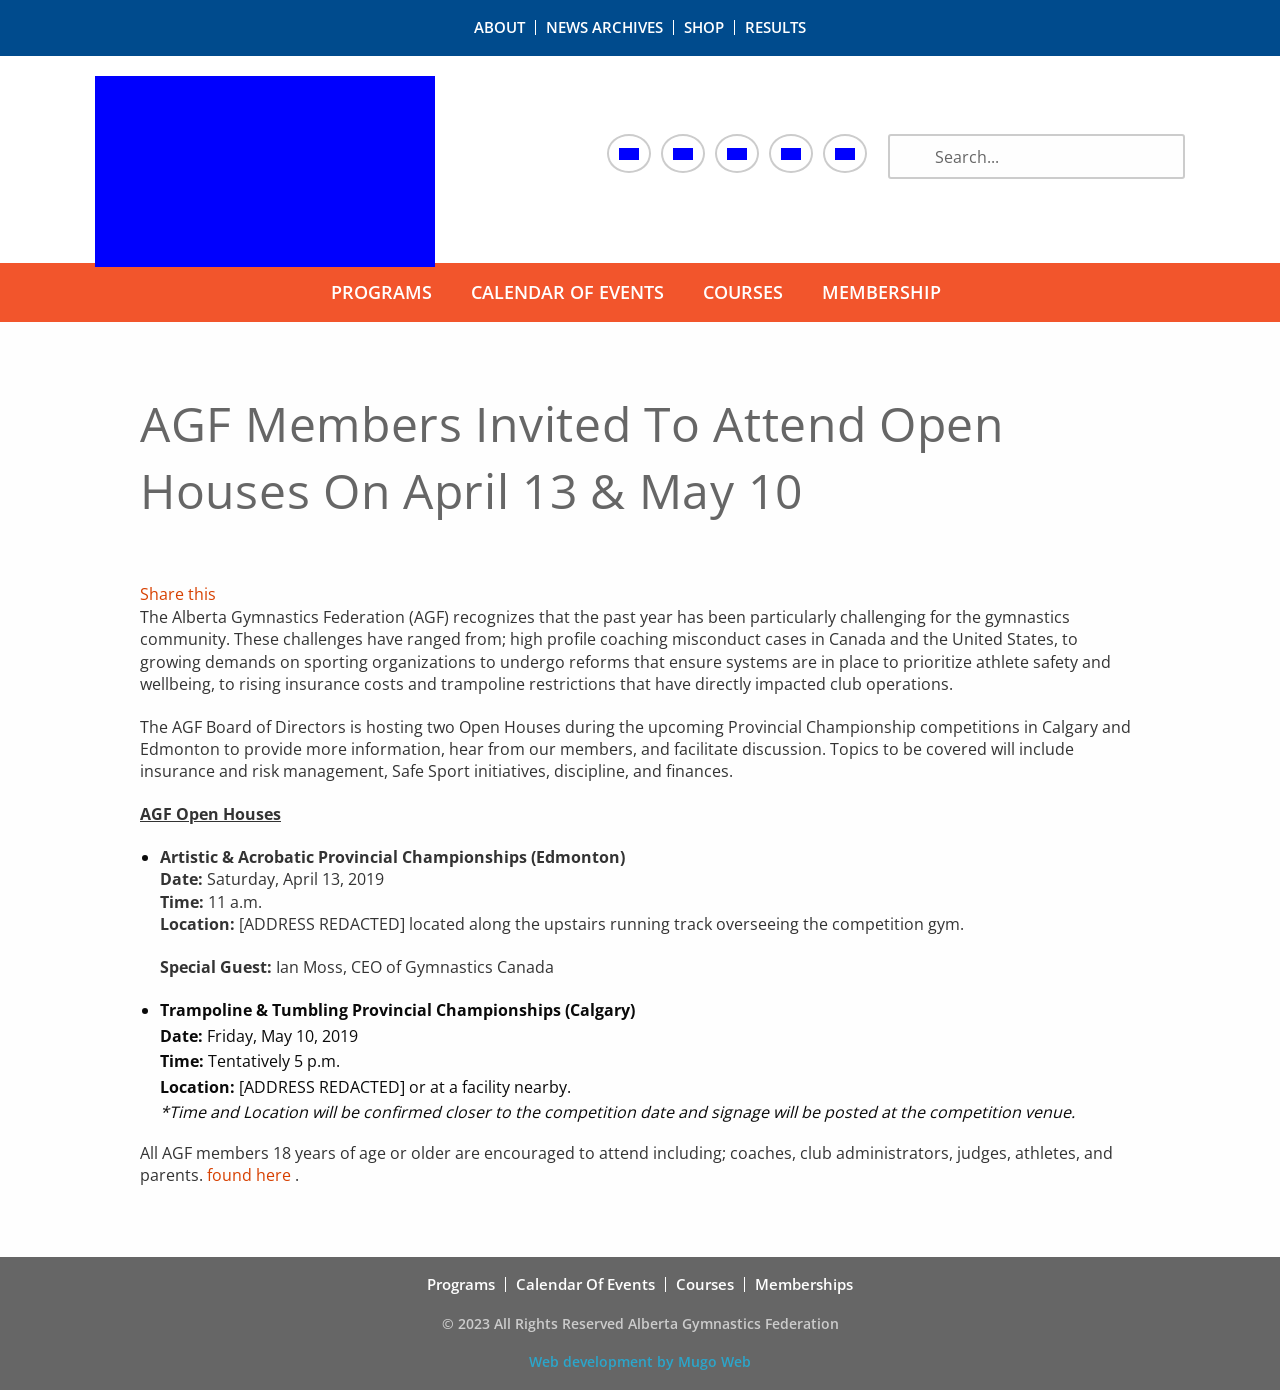What is this announcement about? The announcement is about open houses scheduled by the Alberta Gymnastics Federation (AGF). These events are set to take place on April 13 and May 10, coinciding with the Provincial Championship competitions in Edmonton and Calgary, respectively. The sessions aim to discuss pressing issues such as insurance, risk management, and Safe Sport initiatives, and they will also provide a platform for members to voice their concerns and suggestions. 